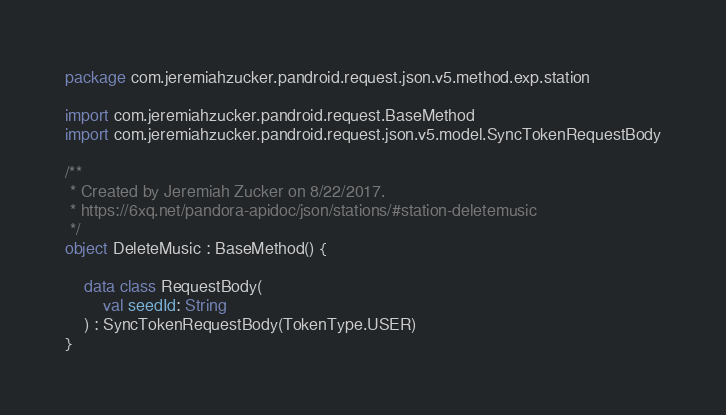Convert code to text. <code><loc_0><loc_0><loc_500><loc_500><_Kotlin_>package com.jeremiahzucker.pandroid.request.json.v5.method.exp.station

import com.jeremiahzucker.pandroid.request.BaseMethod
import com.jeremiahzucker.pandroid.request.json.v5.model.SyncTokenRequestBody

/**
 * Created by Jeremiah Zucker on 8/22/2017.
 * https://6xq.net/pandora-apidoc/json/stations/#station-deletemusic
 */
object DeleteMusic : BaseMethod() {

    data class RequestBody(
        val seedId: String
    ) : SyncTokenRequestBody(TokenType.USER)
}
</code> 